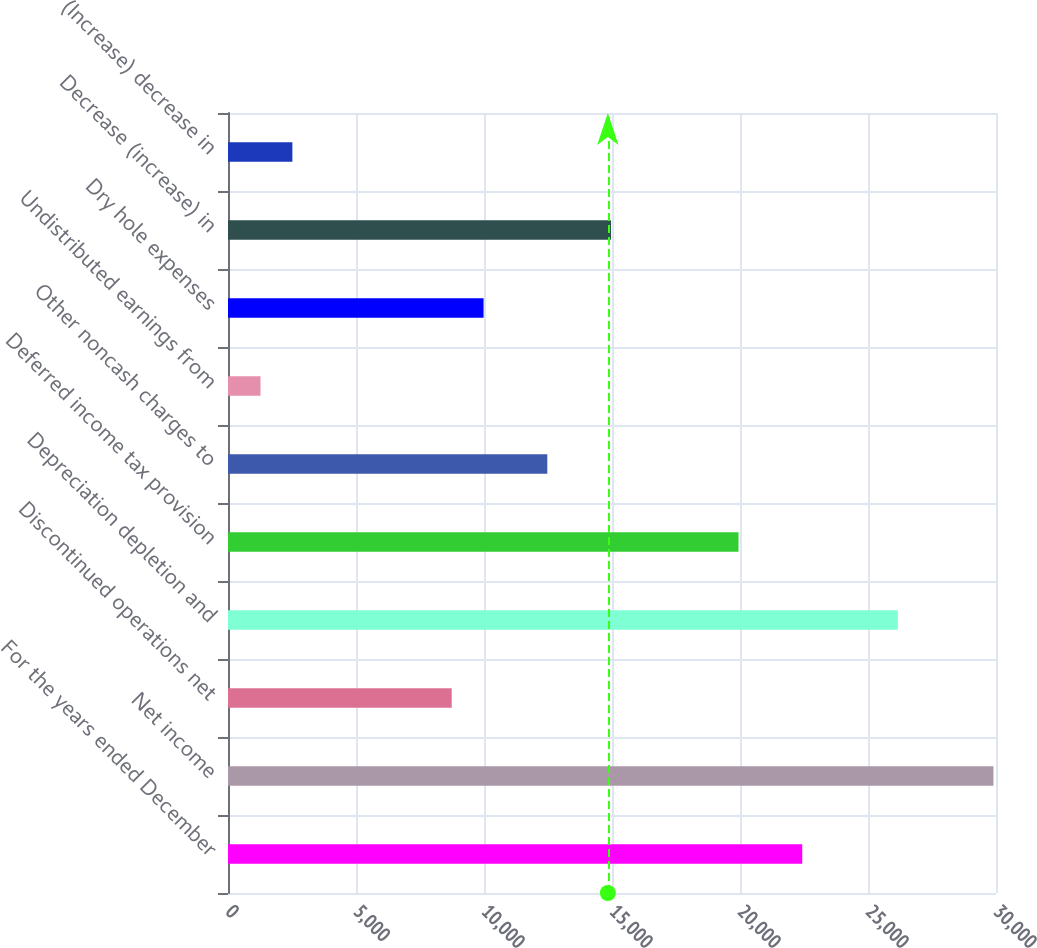Convert chart to OTSL. <chart><loc_0><loc_0><loc_500><loc_500><bar_chart><fcel>For the years ended December<fcel>Net income<fcel>Discontinued operations net<fcel>Depreciation depletion and<fcel>Deferred income tax provision<fcel>Other noncash charges to<fcel>Undistributed earnings from<fcel>Dry hole expenses<fcel>Decrease (increase) in<fcel>(Increase) decrease in<nl><fcel>22431.4<fcel>29900.2<fcel>8738.6<fcel>26165.8<fcel>19941.8<fcel>12473<fcel>1269.8<fcel>9983.4<fcel>14962.6<fcel>2514.6<nl></chart> 